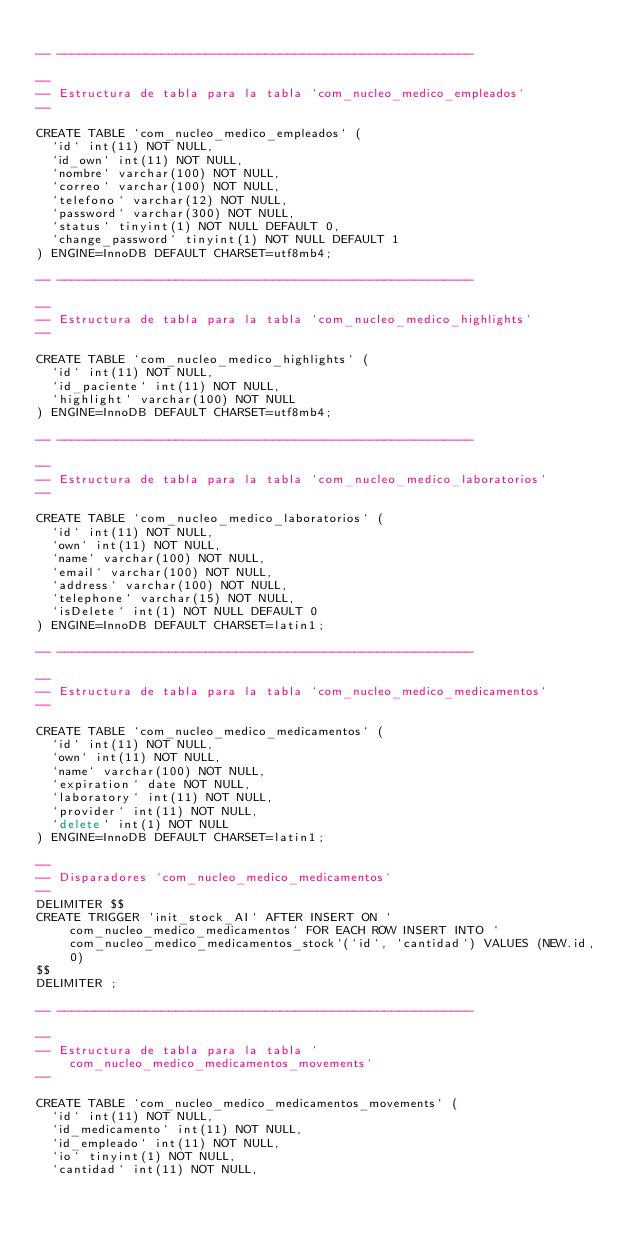<code> <loc_0><loc_0><loc_500><loc_500><_SQL_>
-- --------------------------------------------------------

--
-- Estructura de tabla para la tabla `com_nucleo_medico_empleados`
--

CREATE TABLE `com_nucleo_medico_empleados` (
  `id` int(11) NOT NULL,
  `id_own` int(11) NOT NULL,
  `nombre` varchar(100) NOT NULL,
  `correo` varchar(100) NOT NULL,
  `telefono` varchar(12) NOT NULL,
  `password` varchar(300) NOT NULL,
  `status` tinyint(1) NOT NULL DEFAULT 0,
  `change_password` tinyint(1) NOT NULL DEFAULT 1
) ENGINE=InnoDB DEFAULT CHARSET=utf8mb4;

-- --------------------------------------------------------

--
-- Estructura de tabla para la tabla `com_nucleo_medico_highlights`
--

CREATE TABLE `com_nucleo_medico_highlights` (
  `id` int(11) NOT NULL,
  `id_paciente` int(11) NOT NULL,
  `highlight` varchar(100) NOT NULL
) ENGINE=InnoDB DEFAULT CHARSET=utf8mb4;

-- --------------------------------------------------------

--
-- Estructura de tabla para la tabla `com_nucleo_medico_laboratorios`
--

CREATE TABLE `com_nucleo_medico_laboratorios` (
  `id` int(11) NOT NULL,
  `own` int(11) NOT NULL,
  `name` varchar(100) NOT NULL,
  `email` varchar(100) NOT NULL,
  `address` varchar(100) NOT NULL,
  `telephone` varchar(15) NOT NULL,
  `isDelete` int(1) NOT NULL DEFAULT 0
) ENGINE=InnoDB DEFAULT CHARSET=latin1;

-- --------------------------------------------------------

--
-- Estructura de tabla para la tabla `com_nucleo_medico_medicamentos`
--

CREATE TABLE `com_nucleo_medico_medicamentos` (
  `id` int(11) NOT NULL,
  `own` int(11) NOT NULL,
  `name` varchar(100) NOT NULL,
  `expiration` date NOT NULL,
  `laboratory` int(11) NOT NULL,
  `provider` int(11) NOT NULL,
  `delete` int(1) NOT NULL
) ENGINE=InnoDB DEFAULT CHARSET=latin1;

--
-- Disparadores `com_nucleo_medico_medicamentos`
--
DELIMITER $$
CREATE TRIGGER `init_stock_AI` AFTER INSERT ON `com_nucleo_medico_medicamentos` FOR EACH ROW INSERT INTO `com_nucleo_medico_medicamentos_stock`(`id`, `cantidad`) VALUES (NEW.id, 0)
$$
DELIMITER ;

-- --------------------------------------------------------

--
-- Estructura de tabla para la tabla `com_nucleo_medico_medicamentos_movements`
--

CREATE TABLE `com_nucleo_medico_medicamentos_movements` (
  `id` int(11) NOT NULL,
  `id_medicamento` int(11) NOT NULL,
  `id_empleado` int(11) NOT NULL,
  `io` tinyint(1) NOT NULL,
  `cantidad` int(11) NOT NULL,</code> 